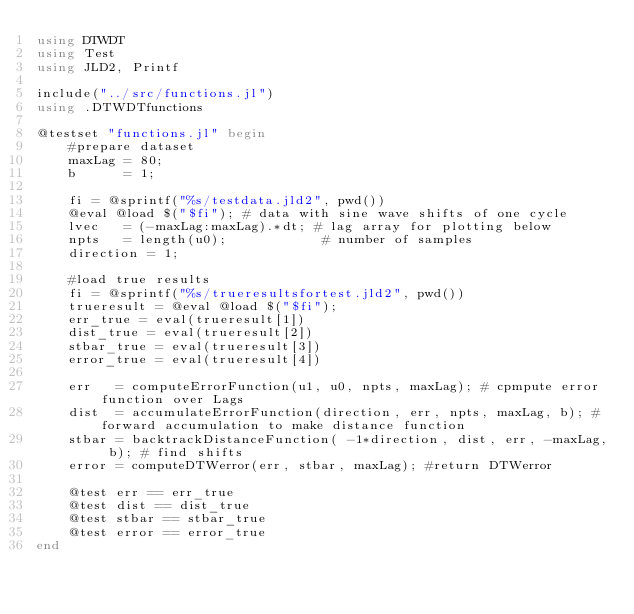<code> <loc_0><loc_0><loc_500><loc_500><_Julia_>using DTWDT
using Test
using JLD2, Printf

include("../src/functions.jl")
using .DTWDTfunctions

@testset "functions.jl" begin
    #prepare dataset
    maxLag = 80;
    b      = 1;

    fi = @sprintf("%s/testdata.jld2", pwd())
    @eval @load $("$fi"); # data with sine wave shifts of one cycle
    lvec   = (-maxLag:maxLag).*dt; # lag array for plotting below
    npts   = length(u0);            # number of samples
    direction = 1;

    #load true results
    fi = @sprintf("%s/trueresultsfortest.jld2", pwd())
    trueresult = @eval @load $("$fi");
    err_true = eval(trueresult[1])
    dist_true = eval(trueresult[2])
    stbar_true = eval(trueresult[3])
    error_true = eval(trueresult[4])

    err   = computeErrorFunction(u1, u0, npts, maxLag); # cpmpute error function over Lags
    dist  = accumulateErrorFunction(direction, err, npts, maxLag, b); # forward accumulation to make distance function
    stbar = backtrackDistanceFunction( -1*direction, dist, err, -maxLag, b); # find shifts
    error = computeDTWerror(err, stbar, maxLag); #return DTWerror

    @test err == err_true
    @test dist == dist_true
    @test stbar == stbar_true
    @test error == error_true
end
</code> 